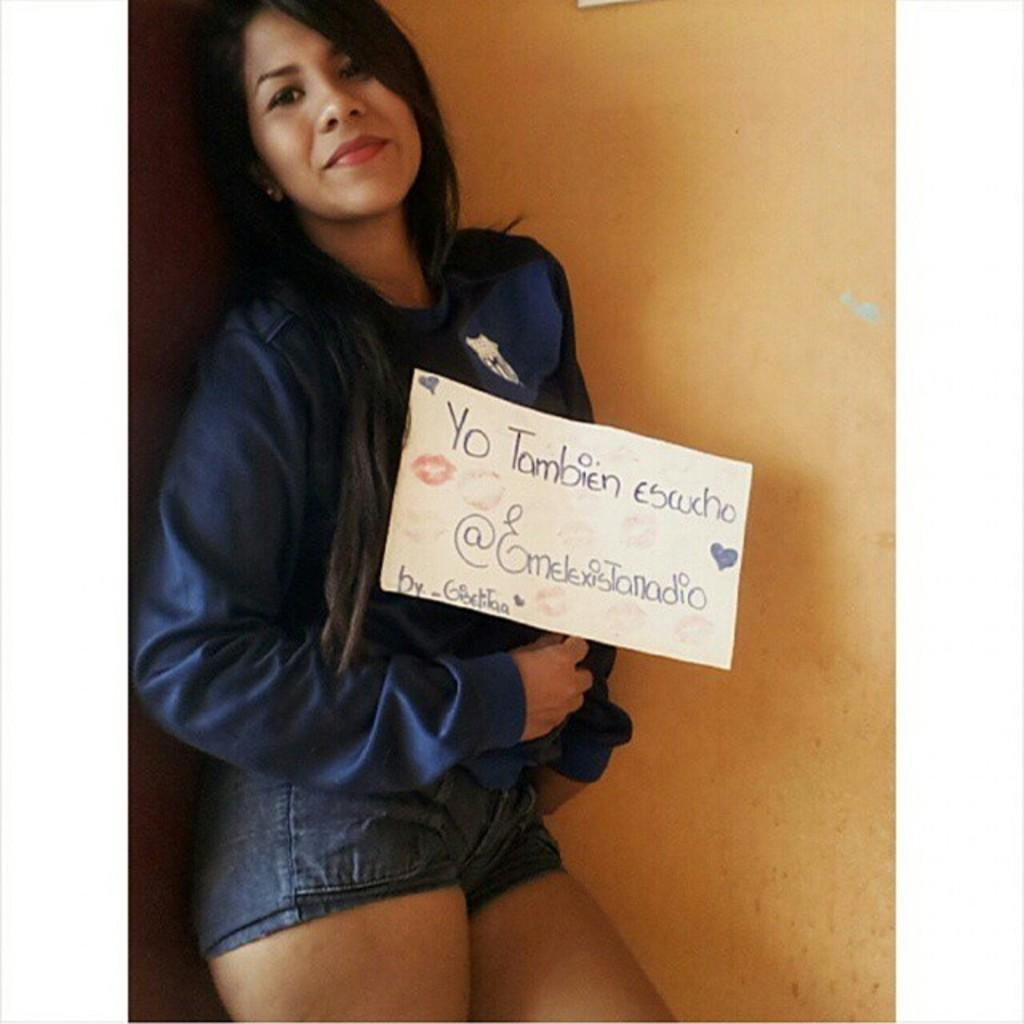What is the main subject of the picture? The main subject of the picture is a woman. What is the woman doing in the picture? The woman is standing in the picture. What is the woman wearing in the picture? The woman is wearing a hoodie and a trouser in the picture. What is the woman holding in the picture? The woman is holding a board in the picture. What can be seen in the background of the picture? There is a yellow color wall in the backdrop of the picture. Can you see any roses in the picture? There are no roses visible in the picture. How does the woman show respect to others in the picture? The picture does not provide any information about the woman showing respect to others. 